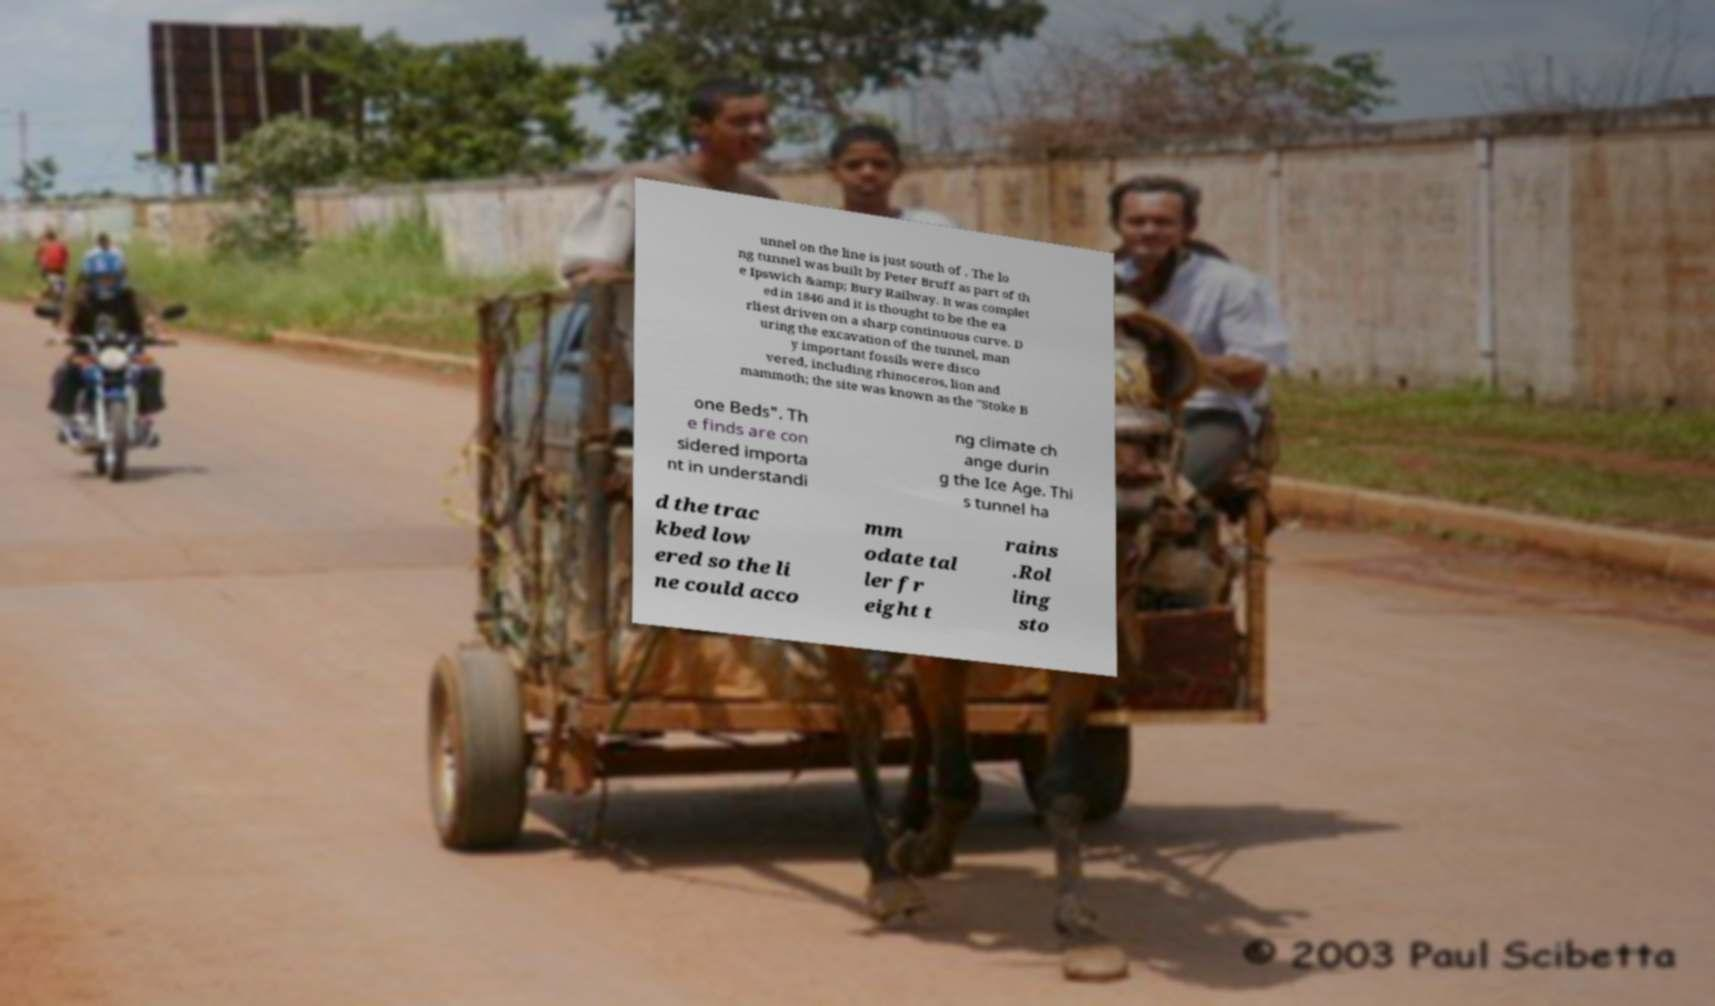Could you assist in decoding the text presented in this image and type it out clearly? unnel on the line is just south of . The lo ng tunnel was built by Peter Bruff as part of th e Ipswich &amp; Bury Railway. It was complet ed in 1846 and it is thought to be the ea rliest driven on a sharp continuous curve. D uring the excavation of the tunnel, man y important fossils were disco vered, including rhinoceros, lion and mammoth; the site was known as the "Stoke B one Beds". Th e finds are con sidered importa nt in understandi ng climate ch ange durin g the Ice Age. Thi s tunnel ha d the trac kbed low ered so the li ne could acco mm odate tal ler fr eight t rains .Rol ling sto 